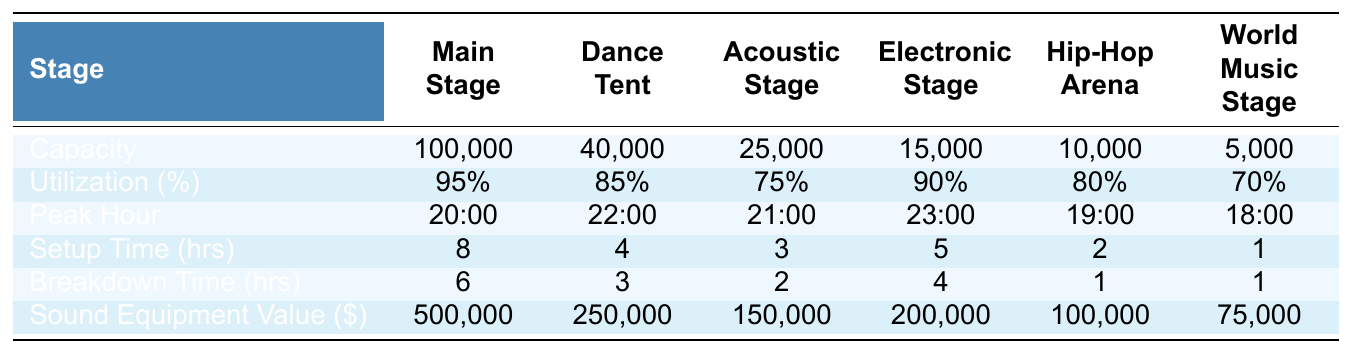What is the capacity of the Main Stage? Referring to the capacity row, the value listed for the Main Stage is 100,000.
Answer: 100,000 Which stage has the lowest utilization percentage? By looking at the utilization percentages, the World Music Stage has the lowest percentage at 70%.
Answer: World Music Stage What is the peak hour of the Electronic Stage? The peak hour for the Electronic Stage is listed as 23:00 in the peak hour row.
Answer: 23:00 What is the total capacity for all stages? Adding the capacities together: 100,000 + 40,000 + 25,000 + 15,000 + 10,000 + 5,000 = 195,000.
Answer: 195,000 Is the Sound Equipment Value for the Dance Tent greater than the Lollapalooza? The Dance Tent has a value of 250,000, while Lollapalooza has 100,000. 250,000 is greater than 100,000, so the answer is yes.
Answer: Yes What is the average setup time for all stages? The setup times are: 8, 4, 3, 5, 2, 1. The total setup time is 8 + 4 + 3 + 5 + 2 + 1 = 23. There are 6 stages, so the average is 23 / 6 ≈ 3.83.
Answer: Approximately 3.83 Which stage has the highest sound equipment value? The highest value is 500,000 for the Main Stage according to the sound equipment value row.
Answer: Main Stage What is the total breakdown time for all stages? Adding the breakdown times: 6 + 3 + 2 + 4 + 1 + 1 = 17.
Answer: 17 Are there any stages with a utilization percentage of 90% or greater? The Main Stage at 95% and the Electronic Stage at 90% both meet this criterion, so yes.
Answer: Yes What is the difference in capacity between the Acoustic Stage and the World Music Stage? The capacity of the Acoustic Stage is 25,000 and the World Music Stage is 5,000. The difference is 25,000 - 5,000 = 20,000.
Answer: 20,000 